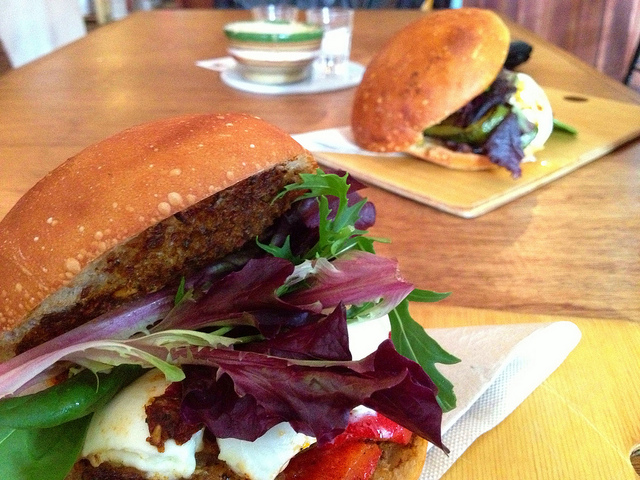This sandwich looks delectable! Can you identify the ingredients used in the sandwiches? The sandwiches appear to be composed of various delicious ingredients. The prominent sandwich in the foreground includes fresh lettuce, arugula, slices of grilled vegetables (such as bell peppers), a slice of cheese, and a patty, all nestled between a well-toasted bun. The sandwich in the background seems to have similar components, including fresh greens, a patty, possibly grilled bell peppers, and cheese within a toasted bun. 